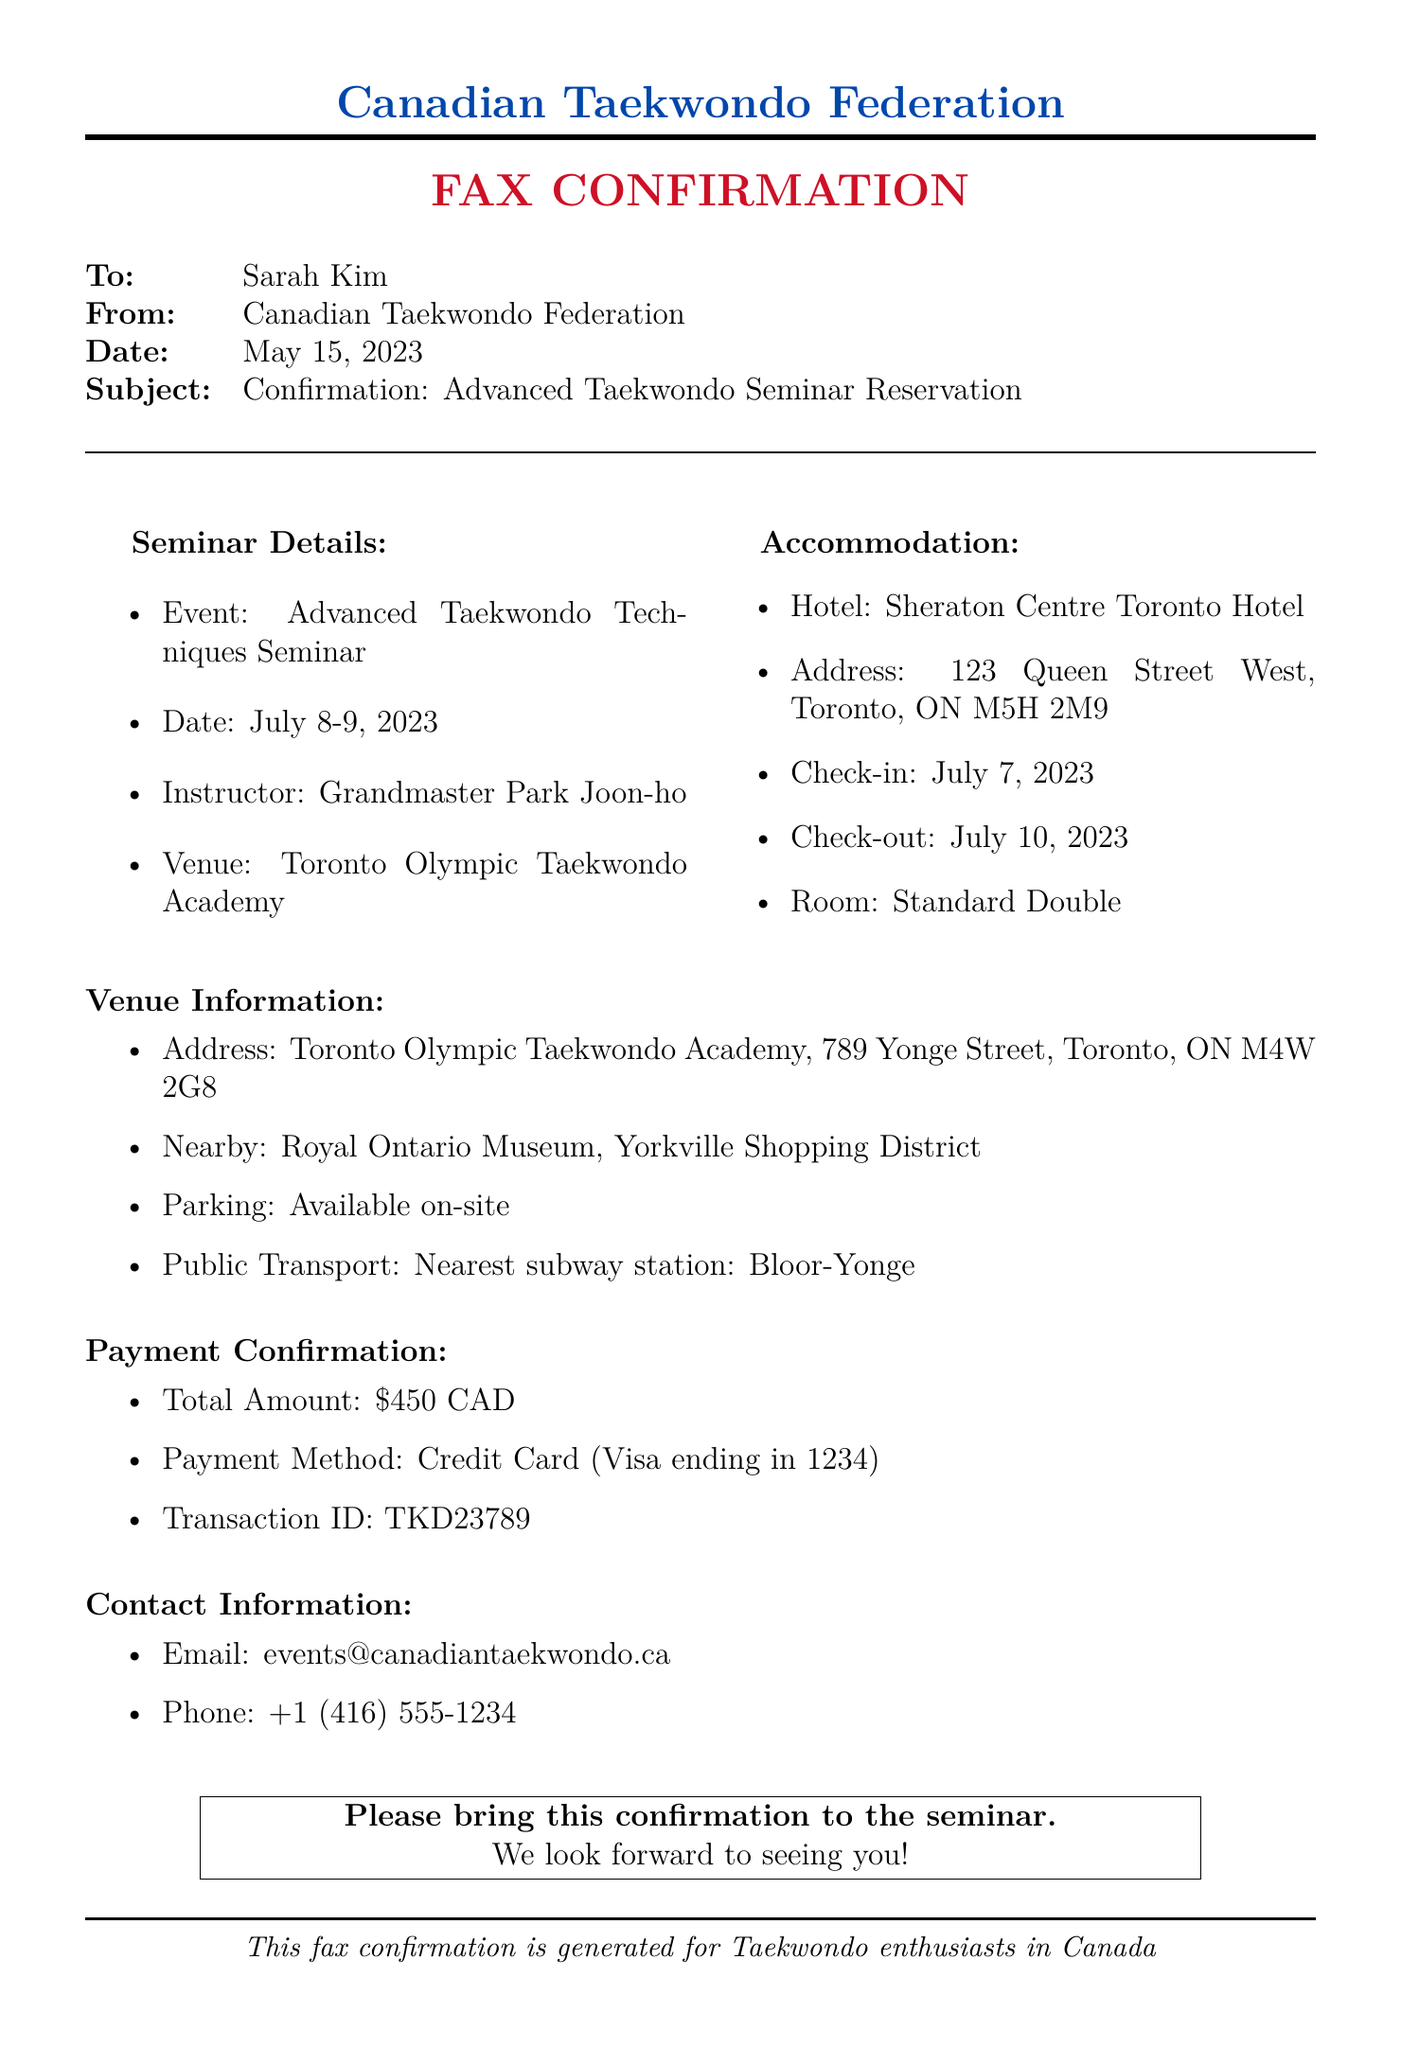What are the seminar dates? The document states the seminar will be held on July 8-9, 2023.
Answer: July 8-9, 2023 Who is the seminar instructor? The document identifies Grandmaster Park Joon-ho as the instructor for the seminar.
Answer: Grandmaster Park Joon-ho What is the total payment amount? The document confirms the total payment amount of $450 CAD.
Answer: $450 CAD Where is the venue located? The address listed for the venue is Toronto Olympic Taekwondo Academy, 789 Yonge Street, Toronto, ON M4W 2G8.
Answer: 789 Yonge Street, Toronto, ON M4W 2G8 What is the check-in date for the accommodation? The document specifies that the check-in date is July 7, 2023.
Answer: July 7, 2023 What hotel will the participants stay at? The document mentions that the accommodation is at Sheraton Centre Toronto Hotel.
Answer: Sheraton Centre Toronto Hotel Which subway station is nearest to the venue? The nearest subway station to the venue is Bloor-Yonge, as mentioned in the document.
Answer: Bloor-Yonge What method of payment was used? The document indicates that the payment method used was a credit card (Visa).
Answer: Credit Card (Visa) What is the contact email provided? The document includes the contact email as events@canadiantaekwondo.ca.
Answer: events@canadiantaekwondo.ca 